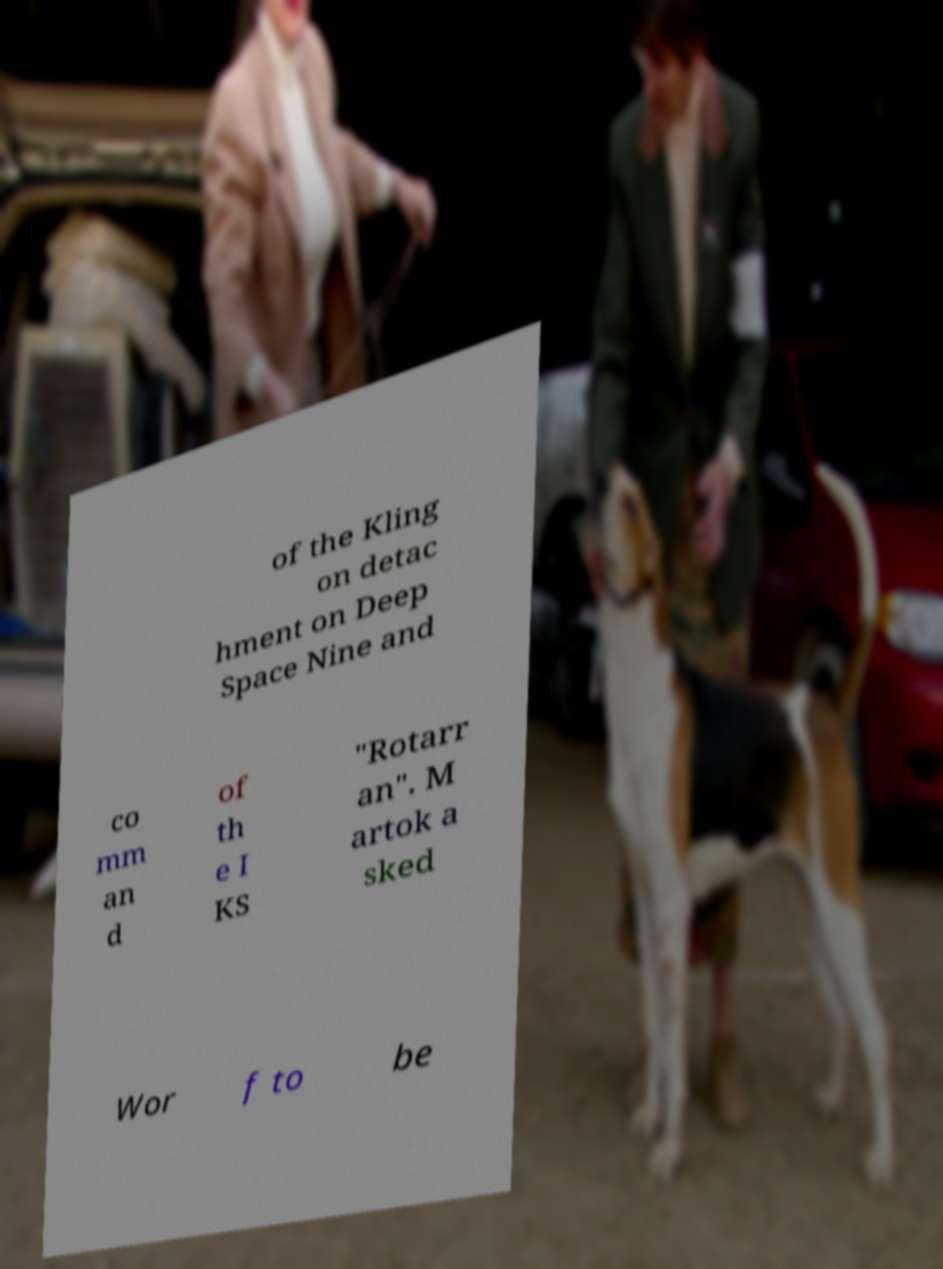Could you assist in decoding the text presented in this image and type it out clearly? of the Kling on detac hment on Deep Space Nine and co mm an d of th e I KS "Rotarr an". M artok a sked Wor f to be 